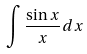<formula> <loc_0><loc_0><loc_500><loc_500>\int \frac { \sin x } { x } d x</formula> 